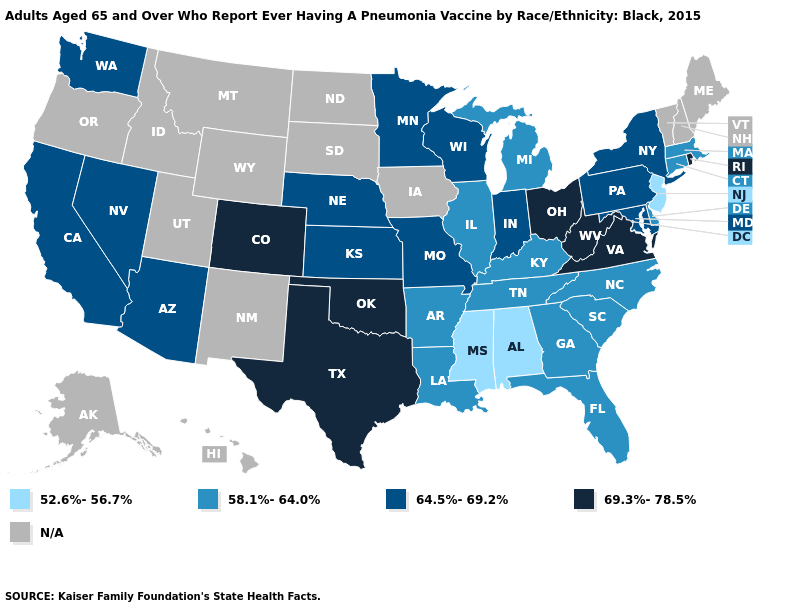Which states have the lowest value in the Northeast?
Be succinct. New Jersey. What is the value of Nevada?
Concise answer only. 64.5%-69.2%. What is the highest value in states that border Texas?
Concise answer only. 69.3%-78.5%. What is the value of Wyoming?
Write a very short answer. N/A. Name the states that have a value in the range 58.1%-64.0%?
Be succinct. Arkansas, Connecticut, Delaware, Florida, Georgia, Illinois, Kentucky, Louisiana, Massachusetts, Michigan, North Carolina, South Carolina, Tennessee. Name the states that have a value in the range 69.3%-78.5%?
Write a very short answer. Colorado, Ohio, Oklahoma, Rhode Island, Texas, Virginia, West Virginia. Which states hav the highest value in the South?
Keep it brief. Oklahoma, Texas, Virginia, West Virginia. What is the lowest value in the USA?
Write a very short answer. 52.6%-56.7%. Among the states that border Michigan , does Wisconsin have the lowest value?
Short answer required. Yes. Name the states that have a value in the range N/A?
Give a very brief answer. Alaska, Hawaii, Idaho, Iowa, Maine, Montana, New Hampshire, New Mexico, North Dakota, Oregon, South Dakota, Utah, Vermont, Wyoming. What is the lowest value in the USA?
Keep it brief. 52.6%-56.7%. Name the states that have a value in the range 58.1%-64.0%?
Quick response, please. Arkansas, Connecticut, Delaware, Florida, Georgia, Illinois, Kentucky, Louisiana, Massachusetts, Michigan, North Carolina, South Carolina, Tennessee. Among the states that border Mississippi , which have the highest value?
Concise answer only. Arkansas, Louisiana, Tennessee. Among the states that border Florida , which have the lowest value?
Quick response, please. Alabama. 